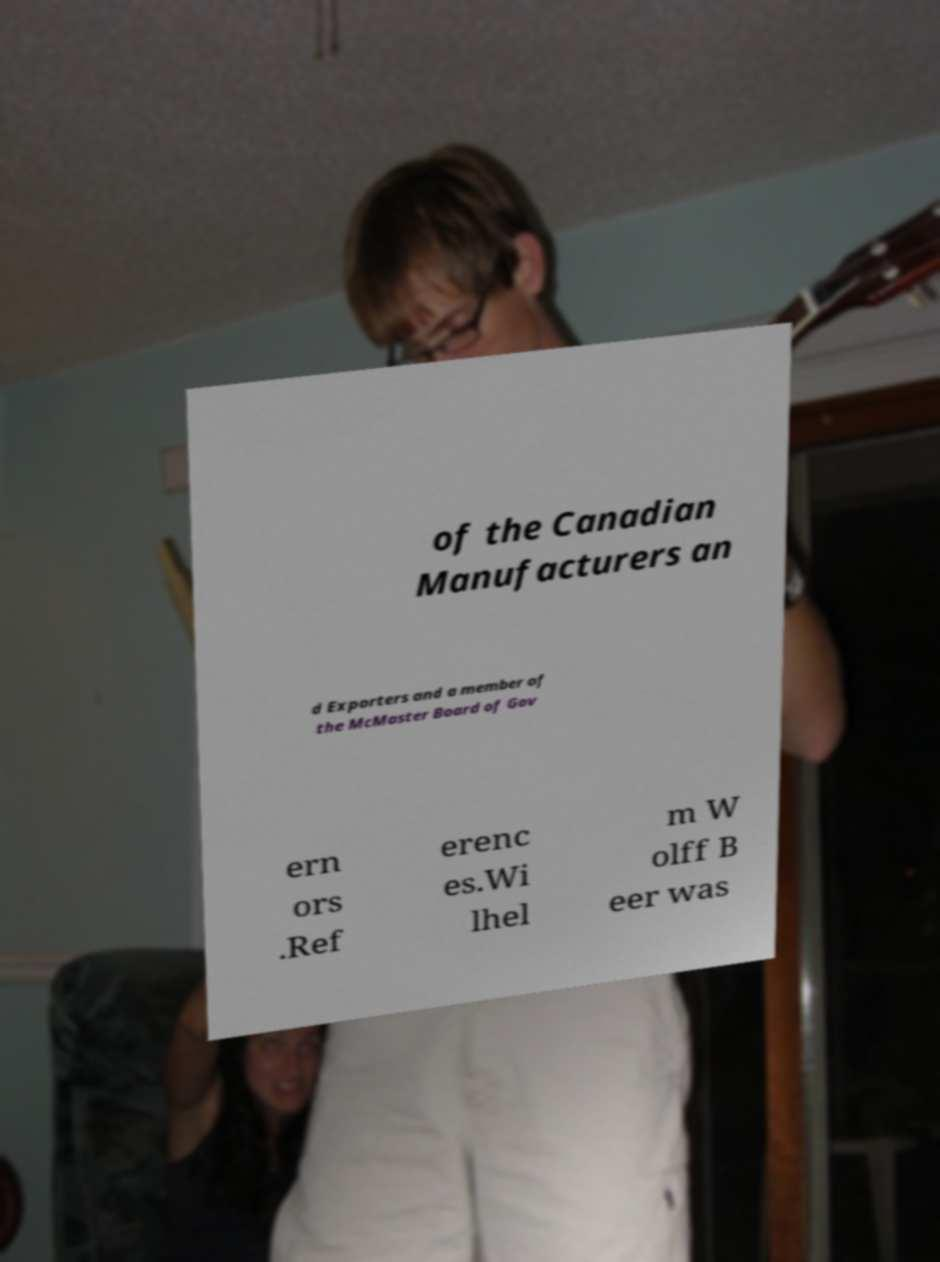Could you assist in decoding the text presented in this image and type it out clearly? of the Canadian Manufacturers an d Exporters and a member of the McMaster Board of Gov ern ors .Ref erenc es.Wi lhel m W olff B eer was 